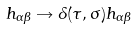<formula> <loc_0><loc_0><loc_500><loc_500>h _ { \alpha \beta } \rightarrow \Lambda ( \tau , \sigma ) h _ { \alpha \beta }</formula> 